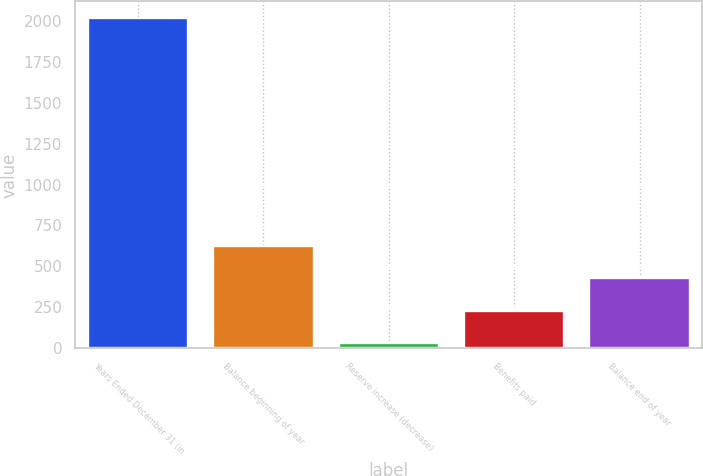Convert chart. <chart><loc_0><loc_0><loc_500><loc_500><bar_chart><fcel>Years Ended December 31 (in<fcel>Balance beginning of year<fcel>Reserve increase (decrease)<fcel>Benefits paid<fcel>Balance end of year<nl><fcel>2016<fcel>627.2<fcel>32<fcel>230.4<fcel>428.8<nl></chart> 